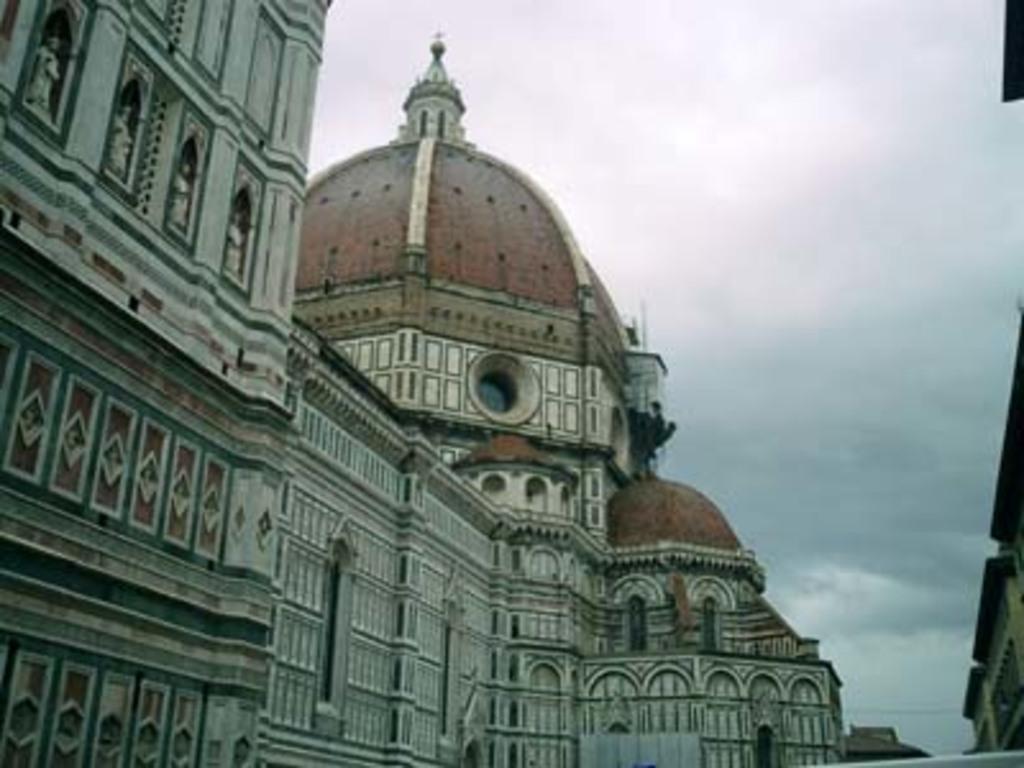In one or two sentences, can you explain what this image depicts? In this image we can see some buildings, a cable and the sky which looks cloudy. 